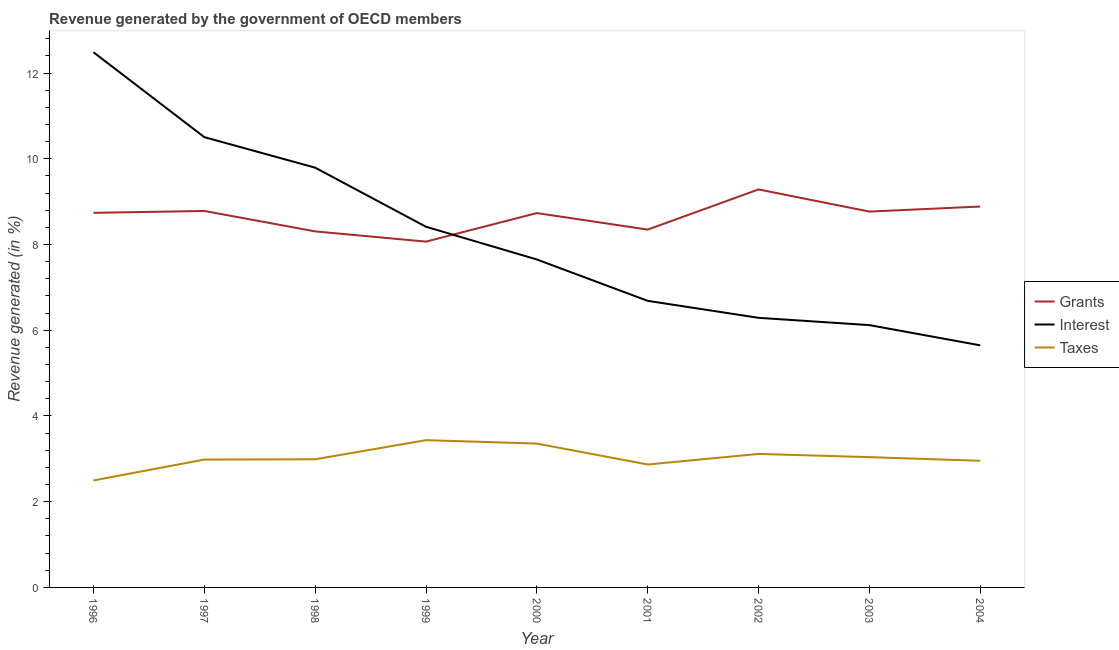How many different coloured lines are there?
Provide a short and direct response. 3. Does the line corresponding to percentage of revenue generated by grants intersect with the line corresponding to percentage of revenue generated by interest?
Provide a succinct answer. Yes. What is the percentage of revenue generated by interest in 1999?
Ensure brevity in your answer.  8.41. Across all years, what is the maximum percentage of revenue generated by interest?
Keep it short and to the point. 12.49. Across all years, what is the minimum percentage of revenue generated by interest?
Ensure brevity in your answer.  5.65. In which year was the percentage of revenue generated by grants maximum?
Make the answer very short. 2002. In which year was the percentage of revenue generated by taxes minimum?
Ensure brevity in your answer.  1996. What is the total percentage of revenue generated by grants in the graph?
Provide a succinct answer. 77.92. What is the difference between the percentage of revenue generated by interest in 1998 and that in 1999?
Offer a terse response. 1.38. What is the difference between the percentage of revenue generated by interest in 2004 and the percentage of revenue generated by taxes in 1996?
Your response must be concise. 3.15. What is the average percentage of revenue generated by grants per year?
Your answer should be compact. 8.66. In the year 2001, what is the difference between the percentage of revenue generated by interest and percentage of revenue generated by grants?
Keep it short and to the point. -1.66. In how many years, is the percentage of revenue generated by taxes greater than 11.2 %?
Your response must be concise. 0. What is the ratio of the percentage of revenue generated by grants in 2001 to that in 2004?
Provide a succinct answer. 0.94. Is the percentage of revenue generated by taxes in 2000 less than that in 2001?
Give a very brief answer. No. What is the difference between the highest and the second highest percentage of revenue generated by taxes?
Your answer should be compact. 0.08. What is the difference between the highest and the lowest percentage of revenue generated by interest?
Provide a short and direct response. 6.84. Is the sum of the percentage of revenue generated by taxes in 1997 and 2003 greater than the maximum percentage of revenue generated by grants across all years?
Ensure brevity in your answer.  No. Is it the case that in every year, the sum of the percentage of revenue generated by grants and percentage of revenue generated by interest is greater than the percentage of revenue generated by taxes?
Give a very brief answer. Yes. Does the percentage of revenue generated by grants monotonically increase over the years?
Provide a short and direct response. No. How many lines are there?
Provide a succinct answer. 3. Are the values on the major ticks of Y-axis written in scientific E-notation?
Provide a succinct answer. No. Does the graph contain any zero values?
Your answer should be very brief. No. Does the graph contain grids?
Offer a very short reply. No. Where does the legend appear in the graph?
Give a very brief answer. Center right. How many legend labels are there?
Provide a short and direct response. 3. What is the title of the graph?
Your answer should be very brief. Revenue generated by the government of OECD members. What is the label or title of the Y-axis?
Provide a succinct answer. Revenue generated (in %). What is the Revenue generated (in %) of Grants in 1996?
Your answer should be very brief. 8.74. What is the Revenue generated (in %) in Interest in 1996?
Give a very brief answer. 12.49. What is the Revenue generated (in %) of Taxes in 1996?
Offer a very short reply. 2.5. What is the Revenue generated (in %) of Grants in 1997?
Make the answer very short. 8.78. What is the Revenue generated (in %) in Interest in 1997?
Provide a succinct answer. 10.51. What is the Revenue generated (in %) in Taxes in 1997?
Make the answer very short. 2.98. What is the Revenue generated (in %) of Grants in 1998?
Give a very brief answer. 8.31. What is the Revenue generated (in %) of Interest in 1998?
Ensure brevity in your answer.  9.79. What is the Revenue generated (in %) in Taxes in 1998?
Keep it short and to the point. 2.99. What is the Revenue generated (in %) in Grants in 1999?
Your answer should be very brief. 8.07. What is the Revenue generated (in %) of Interest in 1999?
Your response must be concise. 8.41. What is the Revenue generated (in %) in Taxes in 1999?
Keep it short and to the point. 3.44. What is the Revenue generated (in %) in Grants in 2000?
Provide a succinct answer. 8.73. What is the Revenue generated (in %) in Interest in 2000?
Offer a very short reply. 7.65. What is the Revenue generated (in %) in Taxes in 2000?
Your answer should be very brief. 3.36. What is the Revenue generated (in %) of Grants in 2001?
Keep it short and to the point. 8.35. What is the Revenue generated (in %) of Interest in 2001?
Offer a very short reply. 6.69. What is the Revenue generated (in %) of Taxes in 2001?
Your response must be concise. 2.87. What is the Revenue generated (in %) of Grants in 2002?
Give a very brief answer. 9.29. What is the Revenue generated (in %) in Interest in 2002?
Give a very brief answer. 6.29. What is the Revenue generated (in %) of Taxes in 2002?
Provide a short and direct response. 3.11. What is the Revenue generated (in %) in Grants in 2003?
Make the answer very short. 8.77. What is the Revenue generated (in %) in Interest in 2003?
Give a very brief answer. 6.12. What is the Revenue generated (in %) of Taxes in 2003?
Your response must be concise. 3.04. What is the Revenue generated (in %) of Grants in 2004?
Your answer should be compact. 8.89. What is the Revenue generated (in %) in Interest in 2004?
Your answer should be compact. 5.65. What is the Revenue generated (in %) in Taxes in 2004?
Your response must be concise. 2.95. Across all years, what is the maximum Revenue generated (in %) in Grants?
Provide a short and direct response. 9.29. Across all years, what is the maximum Revenue generated (in %) in Interest?
Your response must be concise. 12.49. Across all years, what is the maximum Revenue generated (in %) in Taxes?
Your response must be concise. 3.44. Across all years, what is the minimum Revenue generated (in %) of Grants?
Make the answer very short. 8.07. Across all years, what is the minimum Revenue generated (in %) of Interest?
Your answer should be compact. 5.65. Across all years, what is the minimum Revenue generated (in %) of Taxes?
Offer a terse response. 2.5. What is the total Revenue generated (in %) of Grants in the graph?
Give a very brief answer. 77.92. What is the total Revenue generated (in %) of Interest in the graph?
Give a very brief answer. 73.6. What is the total Revenue generated (in %) in Taxes in the graph?
Keep it short and to the point. 27.24. What is the difference between the Revenue generated (in %) of Grants in 1996 and that in 1997?
Make the answer very short. -0.04. What is the difference between the Revenue generated (in %) of Interest in 1996 and that in 1997?
Ensure brevity in your answer.  1.98. What is the difference between the Revenue generated (in %) in Taxes in 1996 and that in 1997?
Keep it short and to the point. -0.49. What is the difference between the Revenue generated (in %) of Grants in 1996 and that in 1998?
Give a very brief answer. 0.43. What is the difference between the Revenue generated (in %) of Interest in 1996 and that in 1998?
Offer a very short reply. 2.69. What is the difference between the Revenue generated (in %) of Taxes in 1996 and that in 1998?
Give a very brief answer. -0.49. What is the difference between the Revenue generated (in %) in Grants in 1996 and that in 1999?
Ensure brevity in your answer.  0.67. What is the difference between the Revenue generated (in %) of Interest in 1996 and that in 1999?
Make the answer very short. 4.07. What is the difference between the Revenue generated (in %) in Taxes in 1996 and that in 1999?
Offer a very short reply. -0.94. What is the difference between the Revenue generated (in %) in Grants in 1996 and that in 2000?
Offer a terse response. 0.01. What is the difference between the Revenue generated (in %) in Interest in 1996 and that in 2000?
Give a very brief answer. 4.84. What is the difference between the Revenue generated (in %) in Taxes in 1996 and that in 2000?
Offer a very short reply. -0.86. What is the difference between the Revenue generated (in %) of Grants in 1996 and that in 2001?
Give a very brief answer. 0.39. What is the difference between the Revenue generated (in %) in Interest in 1996 and that in 2001?
Offer a terse response. 5.8. What is the difference between the Revenue generated (in %) of Taxes in 1996 and that in 2001?
Offer a terse response. -0.37. What is the difference between the Revenue generated (in %) in Grants in 1996 and that in 2002?
Make the answer very short. -0.55. What is the difference between the Revenue generated (in %) of Interest in 1996 and that in 2002?
Offer a terse response. 6.2. What is the difference between the Revenue generated (in %) of Taxes in 1996 and that in 2002?
Keep it short and to the point. -0.62. What is the difference between the Revenue generated (in %) of Grants in 1996 and that in 2003?
Provide a short and direct response. -0.03. What is the difference between the Revenue generated (in %) of Interest in 1996 and that in 2003?
Offer a terse response. 6.37. What is the difference between the Revenue generated (in %) in Taxes in 1996 and that in 2003?
Your answer should be very brief. -0.54. What is the difference between the Revenue generated (in %) of Grants in 1996 and that in 2004?
Offer a terse response. -0.15. What is the difference between the Revenue generated (in %) in Interest in 1996 and that in 2004?
Provide a short and direct response. 6.84. What is the difference between the Revenue generated (in %) in Taxes in 1996 and that in 2004?
Offer a very short reply. -0.46. What is the difference between the Revenue generated (in %) of Grants in 1997 and that in 1998?
Ensure brevity in your answer.  0.48. What is the difference between the Revenue generated (in %) of Interest in 1997 and that in 1998?
Your response must be concise. 0.71. What is the difference between the Revenue generated (in %) of Taxes in 1997 and that in 1998?
Ensure brevity in your answer.  -0.01. What is the difference between the Revenue generated (in %) of Grants in 1997 and that in 1999?
Your answer should be very brief. 0.72. What is the difference between the Revenue generated (in %) of Interest in 1997 and that in 1999?
Your answer should be compact. 2.09. What is the difference between the Revenue generated (in %) of Taxes in 1997 and that in 1999?
Ensure brevity in your answer.  -0.45. What is the difference between the Revenue generated (in %) in Grants in 1997 and that in 2000?
Offer a terse response. 0.05. What is the difference between the Revenue generated (in %) of Interest in 1997 and that in 2000?
Offer a very short reply. 2.85. What is the difference between the Revenue generated (in %) of Taxes in 1997 and that in 2000?
Make the answer very short. -0.37. What is the difference between the Revenue generated (in %) of Grants in 1997 and that in 2001?
Ensure brevity in your answer.  0.43. What is the difference between the Revenue generated (in %) of Interest in 1997 and that in 2001?
Give a very brief answer. 3.82. What is the difference between the Revenue generated (in %) of Taxes in 1997 and that in 2001?
Offer a terse response. 0.12. What is the difference between the Revenue generated (in %) of Grants in 1997 and that in 2002?
Offer a very short reply. -0.5. What is the difference between the Revenue generated (in %) in Interest in 1997 and that in 2002?
Provide a short and direct response. 4.22. What is the difference between the Revenue generated (in %) of Taxes in 1997 and that in 2002?
Provide a short and direct response. -0.13. What is the difference between the Revenue generated (in %) in Grants in 1997 and that in 2003?
Your answer should be compact. 0.01. What is the difference between the Revenue generated (in %) in Interest in 1997 and that in 2003?
Provide a succinct answer. 4.39. What is the difference between the Revenue generated (in %) of Taxes in 1997 and that in 2003?
Your response must be concise. -0.06. What is the difference between the Revenue generated (in %) in Grants in 1997 and that in 2004?
Your response must be concise. -0.1. What is the difference between the Revenue generated (in %) of Interest in 1997 and that in 2004?
Provide a short and direct response. 4.86. What is the difference between the Revenue generated (in %) of Taxes in 1997 and that in 2004?
Your answer should be very brief. 0.03. What is the difference between the Revenue generated (in %) in Grants in 1998 and that in 1999?
Make the answer very short. 0.24. What is the difference between the Revenue generated (in %) of Interest in 1998 and that in 1999?
Provide a succinct answer. 1.38. What is the difference between the Revenue generated (in %) in Taxes in 1998 and that in 1999?
Give a very brief answer. -0.45. What is the difference between the Revenue generated (in %) in Grants in 1998 and that in 2000?
Your response must be concise. -0.43. What is the difference between the Revenue generated (in %) in Interest in 1998 and that in 2000?
Provide a short and direct response. 2.14. What is the difference between the Revenue generated (in %) of Taxes in 1998 and that in 2000?
Your answer should be very brief. -0.37. What is the difference between the Revenue generated (in %) in Grants in 1998 and that in 2001?
Give a very brief answer. -0.04. What is the difference between the Revenue generated (in %) of Interest in 1998 and that in 2001?
Your answer should be very brief. 3.11. What is the difference between the Revenue generated (in %) in Taxes in 1998 and that in 2001?
Offer a terse response. 0.12. What is the difference between the Revenue generated (in %) in Grants in 1998 and that in 2002?
Give a very brief answer. -0.98. What is the difference between the Revenue generated (in %) of Interest in 1998 and that in 2002?
Provide a short and direct response. 3.5. What is the difference between the Revenue generated (in %) of Taxes in 1998 and that in 2002?
Your response must be concise. -0.12. What is the difference between the Revenue generated (in %) in Grants in 1998 and that in 2003?
Ensure brevity in your answer.  -0.46. What is the difference between the Revenue generated (in %) in Interest in 1998 and that in 2003?
Make the answer very short. 3.67. What is the difference between the Revenue generated (in %) of Taxes in 1998 and that in 2003?
Offer a terse response. -0.05. What is the difference between the Revenue generated (in %) of Grants in 1998 and that in 2004?
Provide a succinct answer. -0.58. What is the difference between the Revenue generated (in %) of Interest in 1998 and that in 2004?
Provide a succinct answer. 4.15. What is the difference between the Revenue generated (in %) in Taxes in 1998 and that in 2004?
Provide a short and direct response. 0.04. What is the difference between the Revenue generated (in %) in Grants in 1999 and that in 2000?
Keep it short and to the point. -0.67. What is the difference between the Revenue generated (in %) in Interest in 1999 and that in 2000?
Offer a very short reply. 0.76. What is the difference between the Revenue generated (in %) in Taxes in 1999 and that in 2000?
Ensure brevity in your answer.  0.08. What is the difference between the Revenue generated (in %) of Grants in 1999 and that in 2001?
Provide a succinct answer. -0.28. What is the difference between the Revenue generated (in %) in Interest in 1999 and that in 2001?
Make the answer very short. 1.73. What is the difference between the Revenue generated (in %) in Taxes in 1999 and that in 2001?
Offer a terse response. 0.57. What is the difference between the Revenue generated (in %) in Grants in 1999 and that in 2002?
Offer a very short reply. -1.22. What is the difference between the Revenue generated (in %) in Interest in 1999 and that in 2002?
Give a very brief answer. 2.12. What is the difference between the Revenue generated (in %) in Taxes in 1999 and that in 2002?
Provide a short and direct response. 0.32. What is the difference between the Revenue generated (in %) in Grants in 1999 and that in 2003?
Your response must be concise. -0.7. What is the difference between the Revenue generated (in %) of Interest in 1999 and that in 2003?
Keep it short and to the point. 2.29. What is the difference between the Revenue generated (in %) of Taxes in 1999 and that in 2003?
Offer a terse response. 0.4. What is the difference between the Revenue generated (in %) of Grants in 1999 and that in 2004?
Keep it short and to the point. -0.82. What is the difference between the Revenue generated (in %) in Interest in 1999 and that in 2004?
Offer a terse response. 2.77. What is the difference between the Revenue generated (in %) of Taxes in 1999 and that in 2004?
Give a very brief answer. 0.48. What is the difference between the Revenue generated (in %) of Grants in 2000 and that in 2001?
Keep it short and to the point. 0.39. What is the difference between the Revenue generated (in %) in Interest in 2000 and that in 2001?
Ensure brevity in your answer.  0.97. What is the difference between the Revenue generated (in %) of Taxes in 2000 and that in 2001?
Make the answer very short. 0.49. What is the difference between the Revenue generated (in %) of Grants in 2000 and that in 2002?
Offer a terse response. -0.55. What is the difference between the Revenue generated (in %) of Interest in 2000 and that in 2002?
Offer a terse response. 1.36. What is the difference between the Revenue generated (in %) of Taxes in 2000 and that in 2002?
Make the answer very short. 0.24. What is the difference between the Revenue generated (in %) of Grants in 2000 and that in 2003?
Make the answer very short. -0.03. What is the difference between the Revenue generated (in %) in Interest in 2000 and that in 2003?
Ensure brevity in your answer.  1.53. What is the difference between the Revenue generated (in %) in Taxes in 2000 and that in 2003?
Make the answer very short. 0.32. What is the difference between the Revenue generated (in %) in Grants in 2000 and that in 2004?
Keep it short and to the point. -0.15. What is the difference between the Revenue generated (in %) of Interest in 2000 and that in 2004?
Provide a short and direct response. 2. What is the difference between the Revenue generated (in %) in Taxes in 2000 and that in 2004?
Ensure brevity in your answer.  0.4. What is the difference between the Revenue generated (in %) of Grants in 2001 and that in 2002?
Provide a short and direct response. -0.94. What is the difference between the Revenue generated (in %) of Interest in 2001 and that in 2002?
Keep it short and to the point. 0.4. What is the difference between the Revenue generated (in %) of Taxes in 2001 and that in 2002?
Your answer should be compact. -0.25. What is the difference between the Revenue generated (in %) of Grants in 2001 and that in 2003?
Give a very brief answer. -0.42. What is the difference between the Revenue generated (in %) in Interest in 2001 and that in 2003?
Your answer should be compact. 0.57. What is the difference between the Revenue generated (in %) in Taxes in 2001 and that in 2003?
Keep it short and to the point. -0.17. What is the difference between the Revenue generated (in %) of Grants in 2001 and that in 2004?
Make the answer very short. -0.54. What is the difference between the Revenue generated (in %) of Interest in 2001 and that in 2004?
Provide a short and direct response. 1.04. What is the difference between the Revenue generated (in %) of Taxes in 2001 and that in 2004?
Your answer should be very brief. -0.09. What is the difference between the Revenue generated (in %) in Grants in 2002 and that in 2003?
Offer a terse response. 0.52. What is the difference between the Revenue generated (in %) of Interest in 2002 and that in 2003?
Offer a very short reply. 0.17. What is the difference between the Revenue generated (in %) in Taxes in 2002 and that in 2003?
Give a very brief answer. 0.08. What is the difference between the Revenue generated (in %) of Grants in 2002 and that in 2004?
Provide a succinct answer. 0.4. What is the difference between the Revenue generated (in %) of Interest in 2002 and that in 2004?
Your answer should be compact. 0.64. What is the difference between the Revenue generated (in %) in Taxes in 2002 and that in 2004?
Give a very brief answer. 0.16. What is the difference between the Revenue generated (in %) in Grants in 2003 and that in 2004?
Your response must be concise. -0.12. What is the difference between the Revenue generated (in %) in Interest in 2003 and that in 2004?
Make the answer very short. 0.47. What is the difference between the Revenue generated (in %) in Taxes in 2003 and that in 2004?
Ensure brevity in your answer.  0.09. What is the difference between the Revenue generated (in %) of Grants in 1996 and the Revenue generated (in %) of Interest in 1997?
Offer a very short reply. -1.77. What is the difference between the Revenue generated (in %) of Grants in 1996 and the Revenue generated (in %) of Taxes in 1997?
Your answer should be compact. 5.76. What is the difference between the Revenue generated (in %) in Interest in 1996 and the Revenue generated (in %) in Taxes in 1997?
Your response must be concise. 9.5. What is the difference between the Revenue generated (in %) in Grants in 1996 and the Revenue generated (in %) in Interest in 1998?
Give a very brief answer. -1.05. What is the difference between the Revenue generated (in %) in Grants in 1996 and the Revenue generated (in %) in Taxes in 1998?
Your answer should be very brief. 5.75. What is the difference between the Revenue generated (in %) of Interest in 1996 and the Revenue generated (in %) of Taxes in 1998?
Your response must be concise. 9.5. What is the difference between the Revenue generated (in %) in Grants in 1996 and the Revenue generated (in %) in Interest in 1999?
Offer a very short reply. 0.33. What is the difference between the Revenue generated (in %) in Grants in 1996 and the Revenue generated (in %) in Taxes in 1999?
Give a very brief answer. 5.3. What is the difference between the Revenue generated (in %) of Interest in 1996 and the Revenue generated (in %) of Taxes in 1999?
Your answer should be very brief. 9.05. What is the difference between the Revenue generated (in %) in Grants in 1996 and the Revenue generated (in %) in Interest in 2000?
Ensure brevity in your answer.  1.09. What is the difference between the Revenue generated (in %) in Grants in 1996 and the Revenue generated (in %) in Taxes in 2000?
Give a very brief answer. 5.38. What is the difference between the Revenue generated (in %) of Interest in 1996 and the Revenue generated (in %) of Taxes in 2000?
Ensure brevity in your answer.  9.13. What is the difference between the Revenue generated (in %) of Grants in 1996 and the Revenue generated (in %) of Interest in 2001?
Offer a very short reply. 2.05. What is the difference between the Revenue generated (in %) in Grants in 1996 and the Revenue generated (in %) in Taxes in 2001?
Keep it short and to the point. 5.87. What is the difference between the Revenue generated (in %) of Interest in 1996 and the Revenue generated (in %) of Taxes in 2001?
Provide a succinct answer. 9.62. What is the difference between the Revenue generated (in %) of Grants in 1996 and the Revenue generated (in %) of Interest in 2002?
Your response must be concise. 2.45. What is the difference between the Revenue generated (in %) in Grants in 1996 and the Revenue generated (in %) in Taxes in 2002?
Make the answer very short. 5.63. What is the difference between the Revenue generated (in %) of Interest in 1996 and the Revenue generated (in %) of Taxes in 2002?
Provide a short and direct response. 9.37. What is the difference between the Revenue generated (in %) of Grants in 1996 and the Revenue generated (in %) of Interest in 2003?
Keep it short and to the point. 2.62. What is the difference between the Revenue generated (in %) of Grants in 1996 and the Revenue generated (in %) of Taxes in 2003?
Offer a very short reply. 5.7. What is the difference between the Revenue generated (in %) of Interest in 1996 and the Revenue generated (in %) of Taxes in 2003?
Make the answer very short. 9.45. What is the difference between the Revenue generated (in %) in Grants in 1996 and the Revenue generated (in %) in Interest in 2004?
Keep it short and to the point. 3.09. What is the difference between the Revenue generated (in %) of Grants in 1996 and the Revenue generated (in %) of Taxes in 2004?
Your answer should be very brief. 5.79. What is the difference between the Revenue generated (in %) of Interest in 1996 and the Revenue generated (in %) of Taxes in 2004?
Provide a short and direct response. 9.53. What is the difference between the Revenue generated (in %) in Grants in 1997 and the Revenue generated (in %) in Interest in 1998?
Ensure brevity in your answer.  -1.01. What is the difference between the Revenue generated (in %) in Grants in 1997 and the Revenue generated (in %) in Taxes in 1998?
Provide a succinct answer. 5.79. What is the difference between the Revenue generated (in %) in Interest in 1997 and the Revenue generated (in %) in Taxes in 1998?
Give a very brief answer. 7.52. What is the difference between the Revenue generated (in %) in Grants in 1997 and the Revenue generated (in %) in Interest in 1999?
Ensure brevity in your answer.  0.37. What is the difference between the Revenue generated (in %) in Grants in 1997 and the Revenue generated (in %) in Taxes in 1999?
Provide a succinct answer. 5.35. What is the difference between the Revenue generated (in %) in Interest in 1997 and the Revenue generated (in %) in Taxes in 1999?
Ensure brevity in your answer.  7.07. What is the difference between the Revenue generated (in %) in Grants in 1997 and the Revenue generated (in %) in Interest in 2000?
Provide a short and direct response. 1.13. What is the difference between the Revenue generated (in %) of Grants in 1997 and the Revenue generated (in %) of Taxes in 2000?
Your answer should be compact. 5.43. What is the difference between the Revenue generated (in %) of Interest in 1997 and the Revenue generated (in %) of Taxes in 2000?
Provide a succinct answer. 7.15. What is the difference between the Revenue generated (in %) of Grants in 1997 and the Revenue generated (in %) of Interest in 2001?
Your response must be concise. 2.1. What is the difference between the Revenue generated (in %) in Grants in 1997 and the Revenue generated (in %) in Taxes in 2001?
Make the answer very short. 5.92. What is the difference between the Revenue generated (in %) of Interest in 1997 and the Revenue generated (in %) of Taxes in 2001?
Your answer should be very brief. 7.64. What is the difference between the Revenue generated (in %) in Grants in 1997 and the Revenue generated (in %) in Interest in 2002?
Offer a terse response. 2.49. What is the difference between the Revenue generated (in %) of Grants in 1997 and the Revenue generated (in %) of Taxes in 2002?
Give a very brief answer. 5.67. What is the difference between the Revenue generated (in %) in Interest in 1997 and the Revenue generated (in %) in Taxes in 2002?
Provide a succinct answer. 7.39. What is the difference between the Revenue generated (in %) of Grants in 1997 and the Revenue generated (in %) of Interest in 2003?
Ensure brevity in your answer.  2.66. What is the difference between the Revenue generated (in %) in Grants in 1997 and the Revenue generated (in %) in Taxes in 2003?
Your response must be concise. 5.74. What is the difference between the Revenue generated (in %) in Interest in 1997 and the Revenue generated (in %) in Taxes in 2003?
Offer a terse response. 7.47. What is the difference between the Revenue generated (in %) in Grants in 1997 and the Revenue generated (in %) in Interest in 2004?
Offer a terse response. 3.13. What is the difference between the Revenue generated (in %) in Grants in 1997 and the Revenue generated (in %) in Taxes in 2004?
Your response must be concise. 5.83. What is the difference between the Revenue generated (in %) in Interest in 1997 and the Revenue generated (in %) in Taxes in 2004?
Your response must be concise. 7.55. What is the difference between the Revenue generated (in %) in Grants in 1998 and the Revenue generated (in %) in Interest in 1999?
Make the answer very short. -0.11. What is the difference between the Revenue generated (in %) of Grants in 1998 and the Revenue generated (in %) of Taxes in 1999?
Your answer should be compact. 4.87. What is the difference between the Revenue generated (in %) of Interest in 1998 and the Revenue generated (in %) of Taxes in 1999?
Ensure brevity in your answer.  6.36. What is the difference between the Revenue generated (in %) in Grants in 1998 and the Revenue generated (in %) in Interest in 2000?
Provide a succinct answer. 0.66. What is the difference between the Revenue generated (in %) of Grants in 1998 and the Revenue generated (in %) of Taxes in 2000?
Make the answer very short. 4.95. What is the difference between the Revenue generated (in %) in Interest in 1998 and the Revenue generated (in %) in Taxes in 2000?
Offer a very short reply. 6.44. What is the difference between the Revenue generated (in %) in Grants in 1998 and the Revenue generated (in %) in Interest in 2001?
Your answer should be very brief. 1.62. What is the difference between the Revenue generated (in %) in Grants in 1998 and the Revenue generated (in %) in Taxes in 2001?
Provide a short and direct response. 5.44. What is the difference between the Revenue generated (in %) of Interest in 1998 and the Revenue generated (in %) of Taxes in 2001?
Ensure brevity in your answer.  6.93. What is the difference between the Revenue generated (in %) of Grants in 1998 and the Revenue generated (in %) of Interest in 2002?
Your answer should be very brief. 2.02. What is the difference between the Revenue generated (in %) of Grants in 1998 and the Revenue generated (in %) of Taxes in 2002?
Ensure brevity in your answer.  5.19. What is the difference between the Revenue generated (in %) of Interest in 1998 and the Revenue generated (in %) of Taxes in 2002?
Your answer should be very brief. 6.68. What is the difference between the Revenue generated (in %) of Grants in 1998 and the Revenue generated (in %) of Interest in 2003?
Ensure brevity in your answer.  2.19. What is the difference between the Revenue generated (in %) of Grants in 1998 and the Revenue generated (in %) of Taxes in 2003?
Provide a short and direct response. 5.27. What is the difference between the Revenue generated (in %) in Interest in 1998 and the Revenue generated (in %) in Taxes in 2003?
Give a very brief answer. 6.75. What is the difference between the Revenue generated (in %) in Grants in 1998 and the Revenue generated (in %) in Interest in 2004?
Your answer should be compact. 2.66. What is the difference between the Revenue generated (in %) of Grants in 1998 and the Revenue generated (in %) of Taxes in 2004?
Offer a terse response. 5.35. What is the difference between the Revenue generated (in %) of Interest in 1998 and the Revenue generated (in %) of Taxes in 2004?
Make the answer very short. 6.84. What is the difference between the Revenue generated (in %) in Grants in 1999 and the Revenue generated (in %) in Interest in 2000?
Offer a very short reply. 0.42. What is the difference between the Revenue generated (in %) of Grants in 1999 and the Revenue generated (in %) of Taxes in 2000?
Provide a short and direct response. 4.71. What is the difference between the Revenue generated (in %) in Interest in 1999 and the Revenue generated (in %) in Taxes in 2000?
Offer a very short reply. 5.06. What is the difference between the Revenue generated (in %) in Grants in 1999 and the Revenue generated (in %) in Interest in 2001?
Your response must be concise. 1.38. What is the difference between the Revenue generated (in %) of Grants in 1999 and the Revenue generated (in %) of Taxes in 2001?
Your answer should be compact. 5.2. What is the difference between the Revenue generated (in %) in Interest in 1999 and the Revenue generated (in %) in Taxes in 2001?
Ensure brevity in your answer.  5.55. What is the difference between the Revenue generated (in %) in Grants in 1999 and the Revenue generated (in %) in Interest in 2002?
Your answer should be compact. 1.78. What is the difference between the Revenue generated (in %) in Grants in 1999 and the Revenue generated (in %) in Taxes in 2002?
Keep it short and to the point. 4.95. What is the difference between the Revenue generated (in %) of Interest in 1999 and the Revenue generated (in %) of Taxes in 2002?
Offer a terse response. 5.3. What is the difference between the Revenue generated (in %) of Grants in 1999 and the Revenue generated (in %) of Interest in 2003?
Make the answer very short. 1.95. What is the difference between the Revenue generated (in %) of Grants in 1999 and the Revenue generated (in %) of Taxes in 2003?
Your response must be concise. 5.03. What is the difference between the Revenue generated (in %) of Interest in 1999 and the Revenue generated (in %) of Taxes in 2003?
Give a very brief answer. 5.38. What is the difference between the Revenue generated (in %) in Grants in 1999 and the Revenue generated (in %) in Interest in 2004?
Give a very brief answer. 2.42. What is the difference between the Revenue generated (in %) of Grants in 1999 and the Revenue generated (in %) of Taxes in 2004?
Provide a short and direct response. 5.11. What is the difference between the Revenue generated (in %) of Interest in 1999 and the Revenue generated (in %) of Taxes in 2004?
Make the answer very short. 5.46. What is the difference between the Revenue generated (in %) of Grants in 2000 and the Revenue generated (in %) of Interest in 2001?
Provide a short and direct response. 2.05. What is the difference between the Revenue generated (in %) in Grants in 2000 and the Revenue generated (in %) in Taxes in 2001?
Provide a short and direct response. 5.87. What is the difference between the Revenue generated (in %) in Interest in 2000 and the Revenue generated (in %) in Taxes in 2001?
Your response must be concise. 4.78. What is the difference between the Revenue generated (in %) of Grants in 2000 and the Revenue generated (in %) of Interest in 2002?
Offer a very short reply. 2.44. What is the difference between the Revenue generated (in %) of Grants in 2000 and the Revenue generated (in %) of Taxes in 2002?
Keep it short and to the point. 5.62. What is the difference between the Revenue generated (in %) of Interest in 2000 and the Revenue generated (in %) of Taxes in 2002?
Make the answer very short. 4.54. What is the difference between the Revenue generated (in %) of Grants in 2000 and the Revenue generated (in %) of Interest in 2003?
Make the answer very short. 2.61. What is the difference between the Revenue generated (in %) of Grants in 2000 and the Revenue generated (in %) of Taxes in 2003?
Offer a very short reply. 5.69. What is the difference between the Revenue generated (in %) in Interest in 2000 and the Revenue generated (in %) in Taxes in 2003?
Provide a short and direct response. 4.61. What is the difference between the Revenue generated (in %) in Grants in 2000 and the Revenue generated (in %) in Interest in 2004?
Offer a terse response. 3.09. What is the difference between the Revenue generated (in %) in Grants in 2000 and the Revenue generated (in %) in Taxes in 2004?
Provide a short and direct response. 5.78. What is the difference between the Revenue generated (in %) of Interest in 2000 and the Revenue generated (in %) of Taxes in 2004?
Make the answer very short. 4.7. What is the difference between the Revenue generated (in %) in Grants in 2001 and the Revenue generated (in %) in Interest in 2002?
Your response must be concise. 2.06. What is the difference between the Revenue generated (in %) of Grants in 2001 and the Revenue generated (in %) of Taxes in 2002?
Your answer should be very brief. 5.23. What is the difference between the Revenue generated (in %) in Interest in 2001 and the Revenue generated (in %) in Taxes in 2002?
Keep it short and to the point. 3.57. What is the difference between the Revenue generated (in %) of Grants in 2001 and the Revenue generated (in %) of Interest in 2003?
Ensure brevity in your answer.  2.23. What is the difference between the Revenue generated (in %) in Grants in 2001 and the Revenue generated (in %) in Taxes in 2003?
Provide a short and direct response. 5.31. What is the difference between the Revenue generated (in %) of Interest in 2001 and the Revenue generated (in %) of Taxes in 2003?
Provide a short and direct response. 3.65. What is the difference between the Revenue generated (in %) of Grants in 2001 and the Revenue generated (in %) of Interest in 2004?
Provide a short and direct response. 2.7. What is the difference between the Revenue generated (in %) in Grants in 2001 and the Revenue generated (in %) in Taxes in 2004?
Offer a very short reply. 5.39. What is the difference between the Revenue generated (in %) in Interest in 2001 and the Revenue generated (in %) in Taxes in 2004?
Provide a short and direct response. 3.73. What is the difference between the Revenue generated (in %) in Grants in 2002 and the Revenue generated (in %) in Interest in 2003?
Offer a terse response. 3.17. What is the difference between the Revenue generated (in %) in Grants in 2002 and the Revenue generated (in %) in Taxes in 2003?
Your response must be concise. 6.25. What is the difference between the Revenue generated (in %) of Interest in 2002 and the Revenue generated (in %) of Taxes in 2003?
Give a very brief answer. 3.25. What is the difference between the Revenue generated (in %) in Grants in 2002 and the Revenue generated (in %) in Interest in 2004?
Your response must be concise. 3.64. What is the difference between the Revenue generated (in %) in Grants in 2002 and the Revenue generated (in %) in Taxes in 2004?
Give a very brief answer. 6.33. What is the difference between the Revenue generated (in %) of Interest in 2002 and the Revenue generated (in %) of Taxes in 2004?
Provide a short and direct response. 3.34. What is the difference between the Revenue generated (in %) of Grants in 2003 and the Revenue generated (in %) of Interest in 2004?
Your response must be concise. 3.12. What is the difference between the Revenue generated (in %) in Grants in 2003 and the Revenue generated (in %) in Taxes in 2004?
Offer a very short reply. 5.81. What is the difference between the Revenue generated (in %) in Interest in 2003 and the Revenue generated (in %) in Taxes in 2004?
Give a very brief answer. 3.17. What is the average Revenue generated (in %) in Grants per year?
Give a very brief answer. 8.66. What is the average Revenue generated (in %) of Interest per year?
Ensure brevity in your answer.  8.18. What is the average Revenue generated (in %) of Taxes per year?
Provide a succinct answer. 3.03. In the year 1996, what is the difference between the Revenue generated (in %) in Grants and Revenue generated (in %) in Interest?
Your answer should be very brief. -3.75. In the year 1996, what is the difference between the Revenue generated (in %) in Grants and Revenue generated (in %) in Taxes?
Give a very brief answer. 6.24. In the year 1996, what is the difference between the Revenue generated (in %) in Interest and Revenue generated (in %) in Taxes?
Make the answer very short. 9.99. In the year 1997, what is the difference between the Revenue generated (in %) in Grants and Revenue generated (in %) in Interest?
Your answer should be compact. -1.72. In the year 1997, what is the difference between the Revenue generated (in %) in Grants and Revenue generated (in %) in Taxes?
Your answer should be compact. 5.8. In the year 1997, what is the difference between the Revenue generated (in %) in Interest and Revenue generated (in %) in Taxes?
Provide a succinct answer. 7.52. In the year 1998, what is the difference between the Revenue generated (in %) of Grants and Revenue generated (in %) of Interest?
Provide a short and direct response. -1.49. In the year 1998, what is the difference between the Revenue generated (in %) in Grants and Revenue generated (in %) in Taxes?
Offer a very short reply. 5.32. In the year 1998, what is the difference between the Revenue generated (in %) in Interest and Revenue generated (in %) in Taxes?
Your answer should be very brief. 6.8. In the year 1999, what is the difference between the Revenue generated (in %) in Grants and Revenue generated (in %) in Interest?
Provide a short and direct response. -0.35. In the year 1999, what is the difference between the Revenue generated (in %) in Grants and Revenue generated (in %) in Taxes?
Your answer should be very brief. 4.63. In the year 1999, what is the difference between the Revenue generated (in %) in Interest and Revenue generated (in %) in Taxes?
Give a very brief answer. 4.98. In the year 2000, what is the difference between the Revenue generated (in %) in Grants and Revenue generated (in %) in Interest?
Your response must be concise. 1.08. In the year 2000, what is the difference between the Revenue generated (in %) in Grants and Revenue generated (in %) in Taxes?
Provide a short and direct response. 5.38. In the year 2000, what is the difference between the Revenue generated (in %) of Interest and Revenue generated (in %) of Taxes?
Offer a terse response. 4.3. In the year 2001, what is the difference between the Revenue generated (in %) of Grants and Revenue generated (in %) of Interest?
Offer a very short reply. 1.66. In the year 2001, what is the difference between the Revenue generated (in %) in Grants and Revenue generated (in %) in Taxes?
Your answer should be compact. 5.48. In the year 2001, what is the difference between the Revenue generated (in %) in Interest and Revenue generated (in %) in Taxes?
Your response must be concise. 3.82. In the year 2002, what is the difference between the Revenue generated (in %) in Grants and Revenue generated (in %) in Interest?
Your answer should be very brief. 3. In the year 2002, what is the difference between the Revenue generated (in %) of Grants and Revenue generated (in %) of Taxes?
Give a very brief answer. 6.17. In the year 2002, what is the difference between the Revenue generated (in %) of Interest and Revenue generated (in %) of Taxes?
Provide a short and direct response. 3.18. In the year 2003, what is the difference between the Revenue generated (in %) in Grants and Revenue generated (in %) in Interest?
Offer a very short reply. 2.65. In the year 2003, what is the difference between the Revenue generated (in %) of Grants and Revenue generated (in %) of Taxes?
Provide a succinct answer. 5.73. In the year 2003, what is the difference between the Revenue generated (in %) in Interest and Revenue generated (in %) in Taxes?
Give a very brief answer. 3.08. In the year 2004, what is the difference between the Revenue generated (in %) in Grants and Revenue generated (in %) in Interest?
Your answer should be compact. 3.24. In the year 2004, what is the difference between the Revenue generated (in %) of Grants and Revenue generated (in %) of Taxes?
Give a very brief answer. 5.93. In the year 2004, what is the difference between the Revenue generated (in %) of Interest and Revenue generated (in %) of Taxes?
Keep it short and to the point. 2.69. What is the ratio of the Revenue generated (in %) in Interest in 1996 to that in 1997?
Provide a short and direct response. 1.19. What is the ratio of the Revenue generated (in %) of Taxes in 1996 to that in 1997?
Offer a very short reply. 0.84. What is the ratio of the Revenue generated (in %) in Grants in 1996 to that in 1998?
Your response must be concise. 1.05. What is the ratio of the Revenue generated (in %) in Interest in 1996 to that in 1998?
Keep it short and to the point. 1.27. What is the ratio of the Revenue generated (in %) of Taxes in 1996 to that in 1998?
Give a very brief answer. 0.83. What is the ratio of the Revenue generated (in %) of Grants in 1996 to that in 1999?
Give a very brief answer. 1.08. What is the ratio of the Revenue generated (in %) of Interest in 1996 to that in 1999?
Make the answer very short. 1.48. What is the ratio of the Revenue generated (in %) in Taxes in 1996 to that in 1999?
Ensure brevity in your answer.  0.73. What is the ratio of the Revenue generated (in %) in Interest in 1996 to that in 2000?
Keep it short and to the point. 1.63. What is the ratio of the Revenue generated (in %) in Taxes in 1996 to that in 2000?
Give a very brief answer. 0.74. What is the ratio of the Revenue generated (in %) of Grants in 1996 to that in 2001?
Give a very brief answer. 1.05. What is the ratio of the Revenue generated (in %) of Interest in 1996 to that in 2001?
Offer a terse response. 1.87. What is the ratio of the Revenue generated (in %) of Taxes in 1996 to that in 2001?
Offer a very short reply. 0.87. What is the ratio of the Revenue generated (in %) of Interest in 1996 to that in 2002?
Your answer should be very brief. 1.99. What is the ratio of the Revenue generated (in %) in Taxes in 1996 to that in 2002?
Offer a very short reply. 0.8. What is the ratio of the Revenue generated (in %) of Interest in 1996 to that in 2003?
Give a very brief answer. 2.04. What is the ratio of the Revenue generated (in %) of Taxes in 1996 to that in 2003?
Make the answer very short. 0.82. What is the ratio of the Revenue generated (in %) in Grants in 1996 to that in 2004?
Give a very brief answer. 0.98. What is the ratio of the Revenue generated (in %) of Interest in 1996 to that in 2004?
Ensure brevity in your answer.  2.21. What is the ratio of the Revenue generated (in %) in Taxes in 1996 to that in 2004?
Your answer should be compact. 0.84. What is the ratio of the Revenue generated (in %) in Grants in 1997 to that in 1998?
Your response must be concise. 1.06. What is the ratio of the Revenue generated (in %) of Interest in 1997 to that in 1998?
Your answer should be very brief. 1.07. What is the ratio of the Revenue generated (in %) of Grants in 1997 to that in 1999?
Provide a succinct answer. 1.09. What is the ratio of the Revenue generated (in %) of Interest in 1997 to that in 1999?
Your answer should be compact. 1.25. What is the ratio of the Revenue generated (in %) of Taxes in 1997 to that in 1999?
Offer a terse response. 0.87. What is the ratio of the Revenue generated (in %) of Grants in 1997 to that in 2000?
Provide a short and direct response. 1.01. What is the ratio of the Revenue generated (in %) of Interest in 1997 to that in 2000?
Make the answer very short. 1.37. What is the ratio of the Revenue generated (in %) in Taxes in 1997 to that in 2000?
Provide a succinct answer. 0.89. What is the ratio of the Revenue generated (in %) of Grants in 1997 to that in 2001?
Offer a terse response. 1.05. What is the ratio of the Revenue generated (in %) in Interest in 1997 to that in 2001?
Your answer should be very brief. 1.57. What is the ratio of the Revenue generated (in %) in Taxes in 1997 to that in 2001?
Offer a terse response. 1.04. What is the ratio of the Revenue generated (in %) in Grants in 1997 to that in 2002?
Provide a succinct answer. 0.95. What is the ratio of the Revenue generated (in %) of Interest in 1997 to that in 2002?
Ensure brevity in your answer.  1.67. What is the ratio of the Revenue generated (in %) in Taxes in 1997 to that in 2002?
Provide a succinct answer. 0.96. What is the ratio of the Revenue generated (in %) in Interest in 1997 to that in 2003?
Keep it short and to the point. 1.72. What is the ratio of the Revenue generated (in %) in Taxes in 1997 to that in 2003?
Give a very brief answer. 0.98. What is the ratio of the Revenue generated (in %) of Grants in 1997 to that in 2004?
Ensure brevity in your answer.  0.99. What is the ratio of the Revenue generated (in %) in Interest in 1997 to that in 2004?
Make the answer very short. 1.86. What is the ratio of the Revenue generated (in %) of Taxes in 1997 to that in 2004?
Provide a short and direct response. 1.01. What is the ratio of the Revenue generated (in %) in Grants in 1998 to that in 1999?
Your answer should be very brief. 1.03. What is the ratio of the Revenue generated (in %) in Interest in 1998 to that in 1999?
Provide a succinct answer. 1.16. What is the ratio of the Revenue generated (in %) of Taxes in 1998 to that in 1999?
Offer a terse response. 0.87. What is the ratio of the Revenue generated (in %) of Grants in 1998 to that in 2000?
Offer a terse response. 0.95. What is the ratio of the Revenue generated (in %) of Interest in 1998 to that in 2000?
Provide a short and direct response. 1.28. What is the ratio of the Revenue generated (in %) of Taxes in 1998 to that in 2000?
Your answer should be compact. 0.89. What is the ratio of the Revenue generated (in %) of Interest in 1998 to that in 2001?
Keep it short and to the point. 1.46. What is the ratio of the Revenue generated (in %) of Taxes in 1998 to that in 2001?
Provide a succinct answer. 1.04. What is the ratio of the Revenue generated (in %) in Grants in 1998 to that in 2002?
Offer a terse response. 0.89. What is the ratio of the Revenue generated (in %) of Interest in 1998 to that in 2002?
Provide a short and direct response. 1.56. What is the ratio of the Revenue generated (in %) of Taxes in 1998 to that in 2002?
Give a very brief answer. 0.96. What is the ratio of the Revenue generated (in %) of Grants in 1998 to that in 2003?
Your answer should be very brief. 0.95. What is the ratio of the Revenue generated (in %) in Interest in 1998 to that in 2003?
Keep it short and to the point. 1.6. What is the ratio of the Revenue generated (in %) in Taxes in 1998 to that in 2003?
Make the answer very short. 0.98. What is the ratio of the Revenue generated (in %) of Grants in 1998 to that in 2004?
Your answer should be compact. 0.93. What is the ratio of the Revenue generated (in %) of Interest in 1998 to that in 2004?
Ensure brevity in your answer.  1.73. What is the ratio of the Revenue generated (in %) of Taxes in 1998 to that in 2004?
Keep it short and to the point. 1.01. What is the ratio of the Revenue generated (in %) of Grants in 1999 to that in 2000?
Provide a short and direct response. 0.92. What is the ratio of the Revenue generated (in %) of Interest in 1999 to that in 2000?
Ensure brevity in your answer.  1.1. What is the ratio of the Revenue generated (in %) in Taxes in 1999 to that in 2000?
Your answer should be compact. 1.02. What is the ratio of the Revenue generated (in %) in Grants in 1999 to that in 2001?
Provide a succinct answer. 0.97. What is the ratio of the Revenue generated (in %) in Interest in 1999 to that in 2001?
Make the answer very short. 1.26. What is the ratio of the Revenue generated (in %) in Taxes in 1999 to that in 2001?
Keep it short and to the point. 1.2. What is the ratio of the Revenue generated (in %) of Grants in 1999 to that in 2002?
Your response must be concise. 0.87. What is the ratio of the Revenue generated (in %) of Interest in 1999 to that in 2002?
Offer a terse response. 1.34. What is the ratio of the Revenue generated (in %) of Taxes in 1999 to that in 2002?
Make the answer very short. 1.1. What is the ratio of the Revenue generated (in %) in Grants in 1999 to that in 2003?
Your response must be concise. 0.92. What is the ratio of the Revenue generated (in %) of Interest in 1999 to that in 2003?
Offer a very short reply. 1.37. What is the ratio of the Revenue generated (in %) in Taxes in 1999 to that in 2003?
Ensure brevity in your answer.  1.13. What is the ratio of the Revenue generated (in %) of Grants in 1999 to that in 2004?
Provide a short and direct response. 0.91. What is the ratio of the Revenue generated (in %) in Interest in 1999 to that in 2004?
Provide a short and direct response. 1.49. What is the ratio of the Revenue generated (in %) in Taxes in 1999 to that in 2004?
Provide a short and direct response. 1.16. What is the ratio of the Revenue generated (in %) in Grants in 2000 to that in 2001?
Give a very brief answer. 1.05. What is the ratio of the Revenue generated (in %) in Interest in 2000 to that in 2001?
Your answer should be very brief. 1.14. What is the ratio of the Revenue generated (in %) of Taxes in 2000 to that in 2001?
Your response must be concise. 1.17. What is the ratio of the Revenue generated (in %) of Grants in 2000 to that in 2002?
Your answer should be compact. 0.94. What is the ratio of the Revenue generated (in %) of Interest in 2000 to that in 2002?
Your answer should be compact. 1.22. What is the ratio of the Revenue generated (in %) in Taxes in 2000 to that in 2002?
Provide a short and direct response. 1.08. What is the ratio of the Revenue generated (in %) of Interest in 2000 to that in 2003?
Your answer should be very brief. 1.25. What is the ratio of the Revenue generated (in %) of Taxes in 2000 to that in 2003?
Give a very brief answer. 1.1. What is the ratio of the Revenue generated (in %) in Grants in 2000 to that in 2004?
Your answer should be compact. 0.98. What is the ratio of the Revenue generated (in %) of Interest in 2000 to that in 2004?
Your response must be concise. 1.35. What is the ratio of the Revenue generated (in %) of Taxes in 2000 to that in 2004?
Make the answer very short. 1.14. What is the ratio of the Revenue generated (in %) of Grants in 2001 to that in 2002?
Your answer should be very brief. 0.9. What is the ratio of the Revenue generated (in %) of Interest in 2001 to that in 2002?
Provide a short and direct response. 1.06. What is the ratio of the Revenue generated (in %) in Taxes in 2001 to that in 2002?
Offer a terse response. 0.92. What is the ratio of the Revenue generated (in %) of Grants in 2001 to that in 2003?
Your answer should be very brief. 0.95. What is the ratio of the Revenue generated (in %) in Interest in 2001 to that in 2003?
Provide a short and direct response. 1.09. What is the ratio of the Revenue generated (in %) of Taxes in 2001 to that in 2003?
Make the answer very short. 0.94. What is the ratio of the Revenue generated (in %) in Grants in 2001 to that in 2004?
Your response must be concise. 0.94. What is the ratio of the Revenue generated (in %) in Interest in 2001 to that in 2004?
Provide a short and direct response. 1.18. What is the ratio of the Revenue generated (in %) in Taxes in 2001 to that in 2004?
Ensure brevity in your answer.  0.97. What is the ratio of the Revenue generated (in %) in Grants in 2002 to that in 2003?
Your response must be concise. 1.06. What is the ratio of the Revenue generated (in %) in Interest in 2002 to that in 2003?
Ensure brevity in your answer.  1.03. What is the ratio of the Revenue generated (in %) of Taxes in 2002 to that in 2003?
Offer a terse response. 1.02. What is the ratio of the Revenue generated (in %) in Grants in 2002 to that in 2004?
Make the answer very short. 1.04. What is the ratio of the Revenue generated (in %) of Interest in 2002 to that in 2004?
Provide a short and direct response. 1.11. What is the ratio of the Revenue generated (in %) of Taxes in 2002 to that in 2004?
Provide a succinct answer. 1.05. What is the ratio of the Revenue generated (in %) in Grants in 2003 to that in 2004?
Offer a terse response. 0.99. What is the ratio of the Revenue generated (in %) in Interest in 2003 to that in 2004?
Your answer should be very brief. 1.08. What is the ratio of the Revenue generated (in %) in Taxes in 2003 to that in 2004?
Provide a short and direct response. 1.03. What is the difference between the highest and the second highest Revenue generated (in %) in Grants?
Give a very brief answer. 0.4. What is the difference between the highest and the second highest Revenue generated (in %) in Interest?
Give a very brief answer. 1.98. What is the difference between the highest and the second highest Revenue generated (in %) of Taxes?
Your answer should be very brief. 0.08. What is the difference between the highest and the lowest Revenue generated (in %) of Grants?
Give a very brief answer. 1.22. What is the difference between the highest and the lowest Revenue generated (in %) in Interest?
Give a very brief answer. 6.84. What is the difference between the highest and the lowest Revenue generated (in %) in Taxes?
Offer a very short reply. 0.94. 